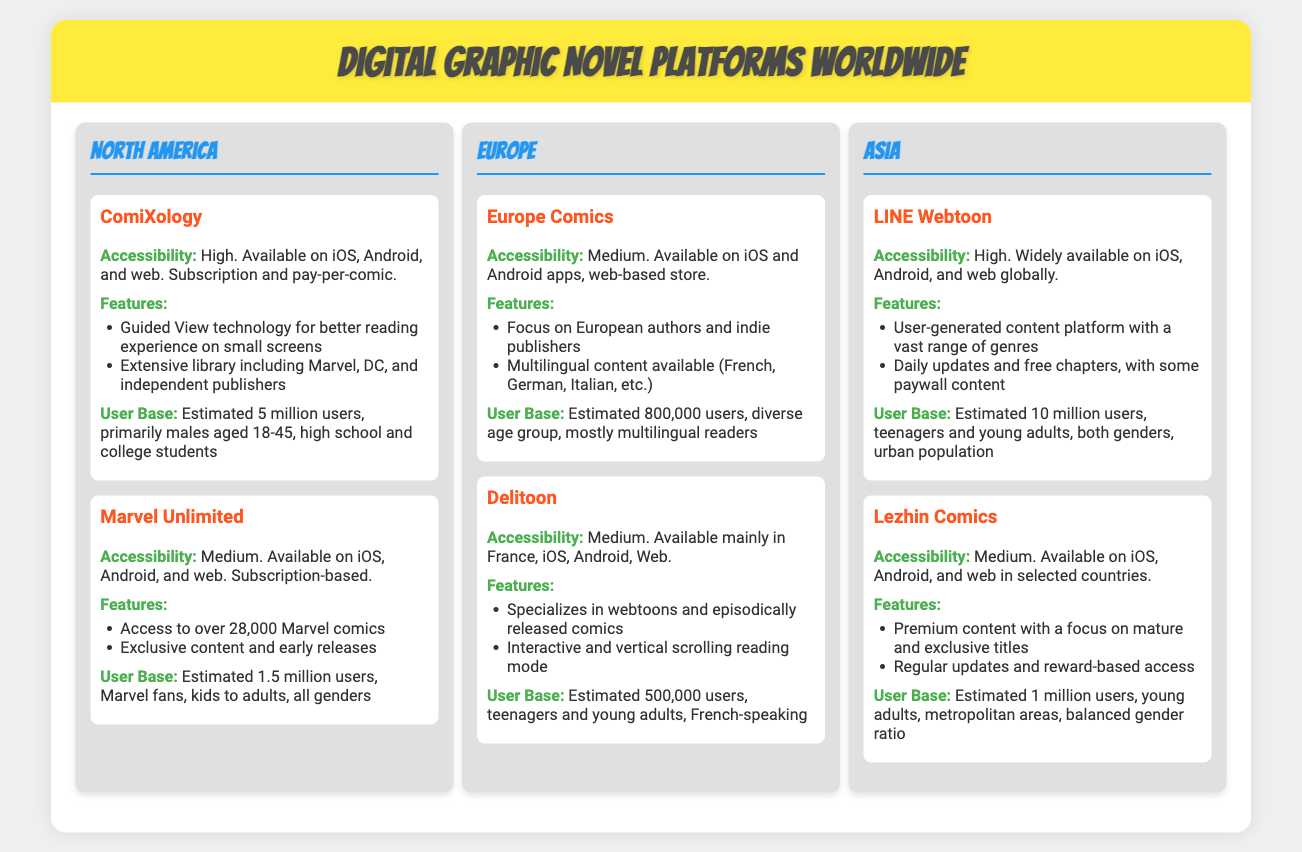What platform has the highest user base in Asia? LINE Webtoon has an estimated user base of 10 million, which is the highest among platforms in Asia.
Answer: LINE Webtoon What region is ComiXology available in? ComiXology is specifically mentioned under the North America region in the document.
Answer: North America What feature does ComiXology offer for smaller screens? ComiXology provides Guided View technology, which enhances the reading experience on smaller devices.
Answer: Guided View technology How many estimated users does Marvel Unlimited have? The document states that Marvel Unlimited has an estimated user base of 1.5 million users.
Answer: 1.5 million users What type of comics does Delitoon specialize in? Delitoon specializes in webtoons and episodically released comics, which is highlighted in the features section.
Answer: Webtoons What is the gender demographic for LINE Webtoon users? The user base for LINE Webtoon consists of both genders, as indicated in the document.
Answer: Both genders Which platform focuses on European authors? Europe Comics focuses on European authors and indie publishers, as stated in the document.
Answer: Europe Comics What is the accessibility level of Lezhin Comics? Lezhin Comics has a medium accessibility level, as mentioned in its description.
Answer: Medium What is the age group of users for Europe Comics? The estimated user base for Europe Comics is described as a diverse age group, reflecting a variety of readers.
Answer: Diverse age group 